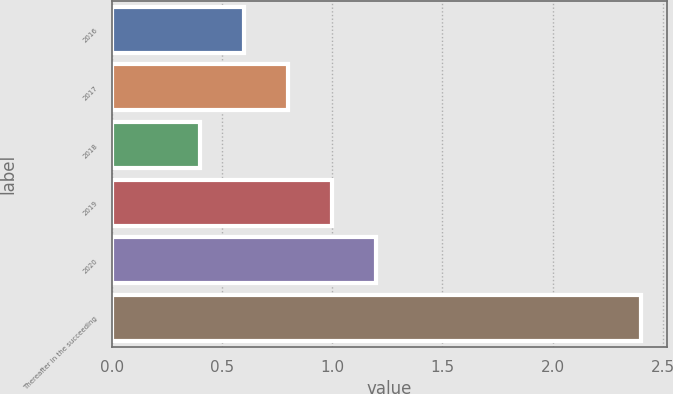<chart> <loc_0><loc_0><loc_500><loc_500><bar_chart><fcel>2016<fcel>2017<fcel>2018<fcel>2019<fcel>2020<fcel>Thereafter in the succeeding<nl><fcel>0.6<fcel>0.8<fcel>0.4<fcel>1<fcel>1.2<fcel>2.4<nl></chart> 